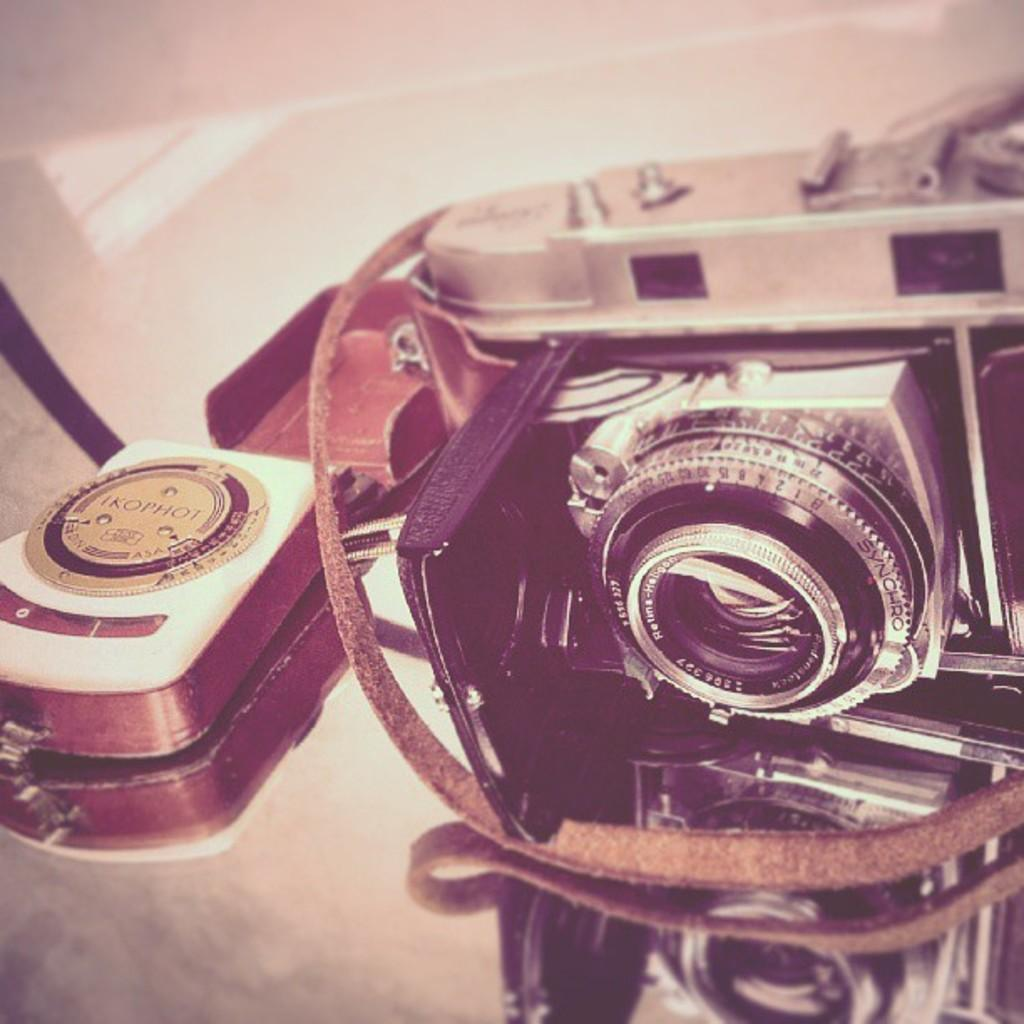What object is the main subject of the image? There is a camera in the image. Where is the camera placed? The camera is placed on a glass surface. What can be seen in the image due to the glass surface? The reflection is visible in the image. What type of honey is dripping from the camera in the image? There is no honey present in the image, and the camera is not dripping anything. 